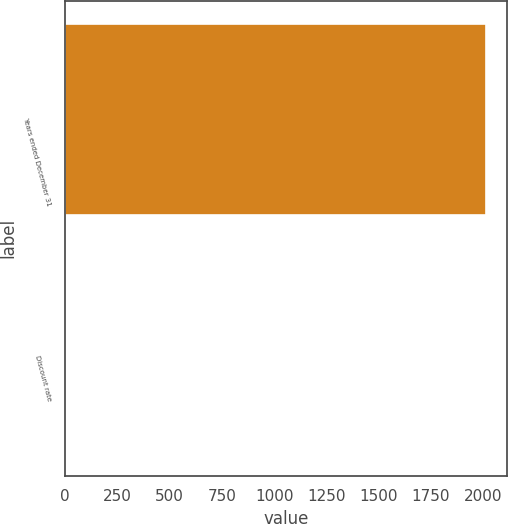Convert chart. <chart><loc_0><loc_0><loc_500><loc_500><bar_chart><fcel>Years ended December 31<fcel>Discount rate<nl><fcel>2013<fcel>4<nl></chart> 